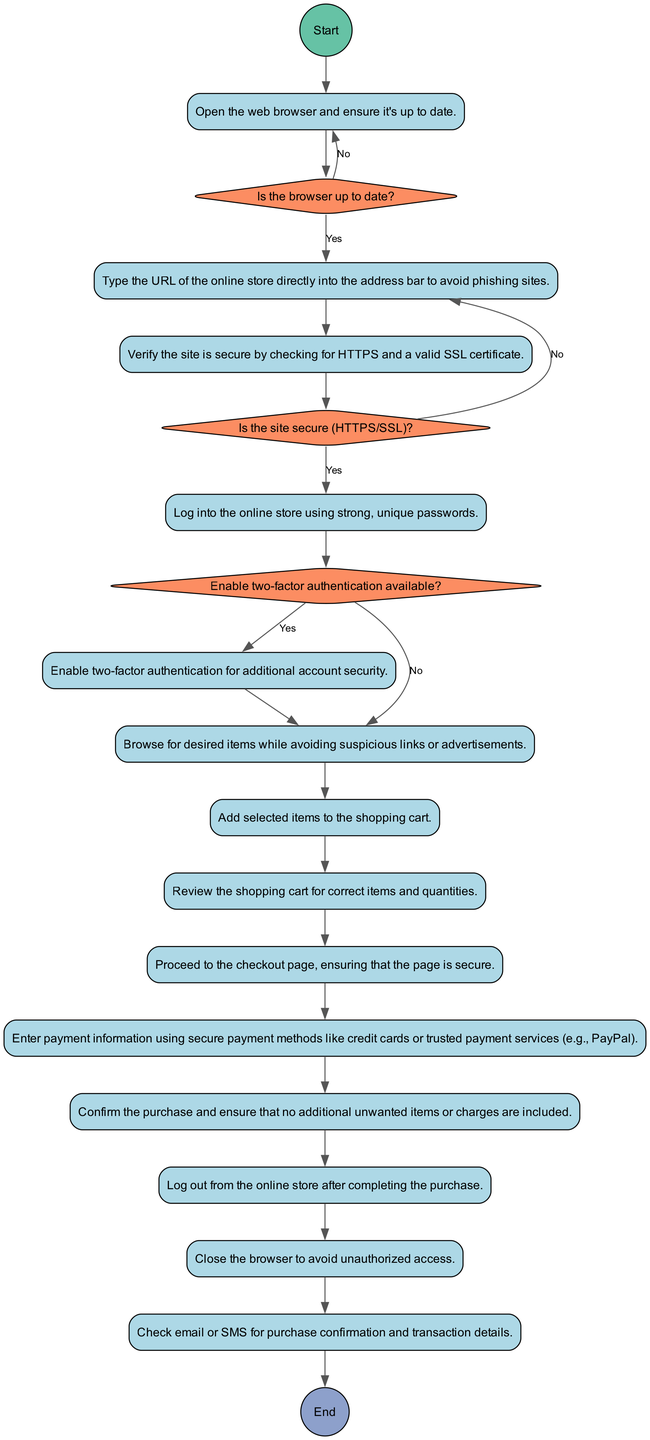What is the first activity in the diagram? The first activity listed in the diagram is "OpenWebBrowser," as specified in the data under "Start."
Answer: OpenWebBrowser How many decisions are present in the diagram? There are three decisions present in the diagram, as indicated in the "Decisions" section of the data.
Answer: 3 What activity comes after "CheckSiteSecurity"? The activity that directly follows "CheckSiteSecurity" in the flow is "LogIn," as shown by the connecting edges in the diagram.
Answer: LogIn If the site is not secure, what will happen next? If the site is not secure, the flow directs back to "NavigateToSite," indicating that the user should not proceed with shopping.
Answer: NavigateToSite What happens if the browser is not up to date? If the browser is not up to date, the diagram indicates the user is directed back to "OpenWebBrowser" to update it before proceeding.
Answer: OpenWebBrowser What are the final two activities in the sequence before verifying the transaction? The last two activities prior to "VerifyTransaction" are "LogOut" and "CloseBrowser," as shown in the last part of the diagram flow.
Answer: LogOut, CloseBrowser Is the two-factor authentication optional in the workflow? Yes, the workflow conditionally allows for "Enable2FA" based on the availability of two-factor authentication, showing it is optional.
Answer: Yes Which activity involves entering payment information? The activity that involves entering payment information is "EnterPaymentInfo," as specified in the sequence of activities.
Answer: EnterPaymentInfo 